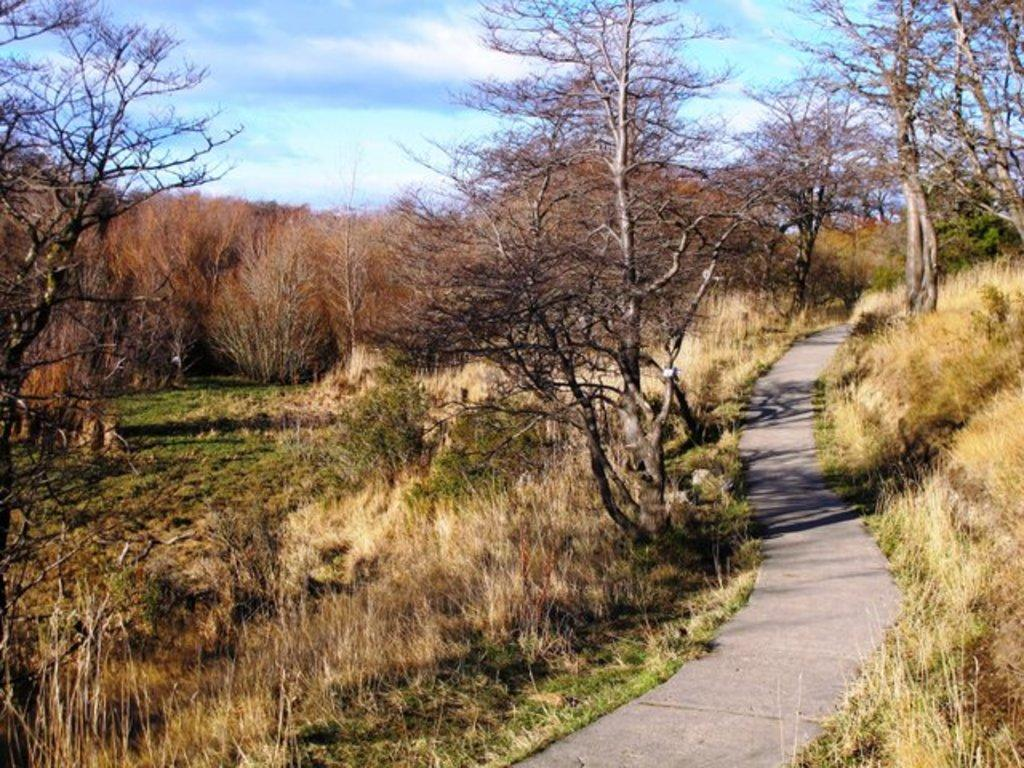What type of vegetation can be seen in the image? There are trees in the image. Can you describe the path visible in the image? There is a path visible between the trees in the image. What type of ground cover is present in the image? There is grass visible in the image. What is the condition of the sky in the image? The sky is cloudy in the image. What type of bread can be seen in the image? There is no bread present in the image. What kind of surprise is hidden among the trees in the image? There is no surprise hidden among the trees in the image. 